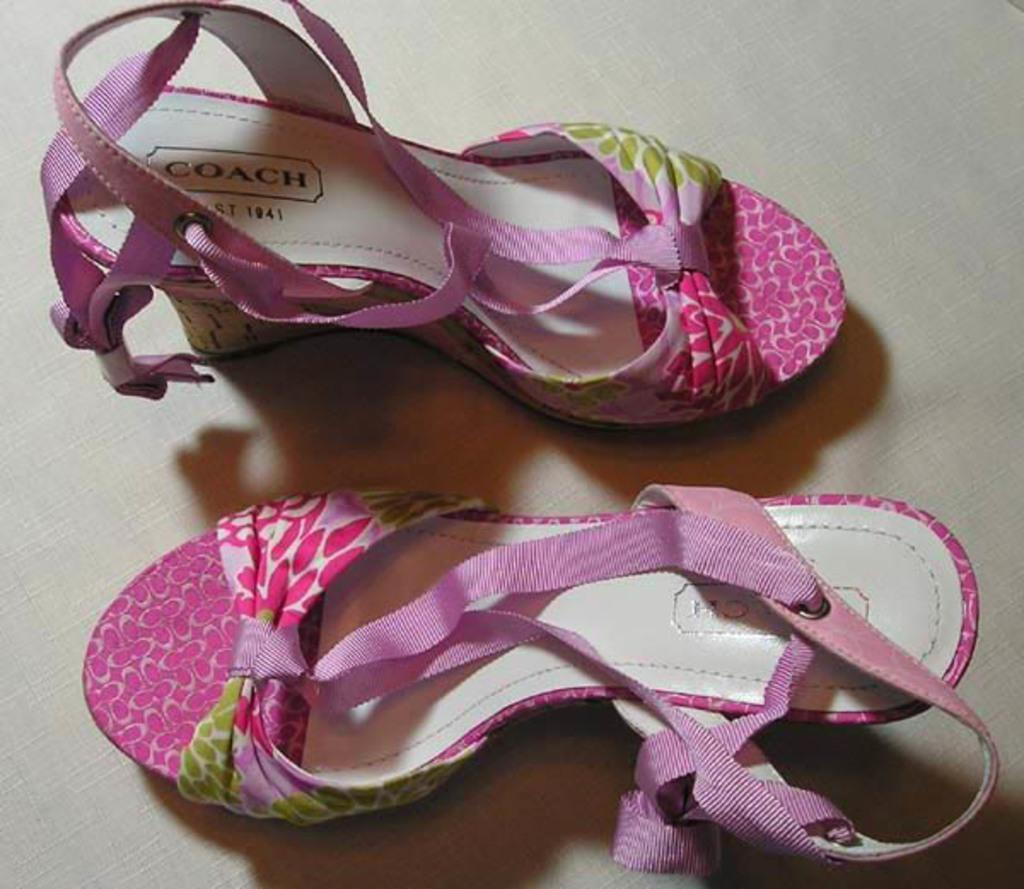What type of object is present in the image? There is footwear in the image. Can you describe the color of the footwear? The footwear has a pink and white color. Is there any text or writing on the footwear? Yes, there is writing on the footwear. What type of advice can be seen written on the window in the image? There is no window present in the image, and therefore no advice can be seen written on it. 